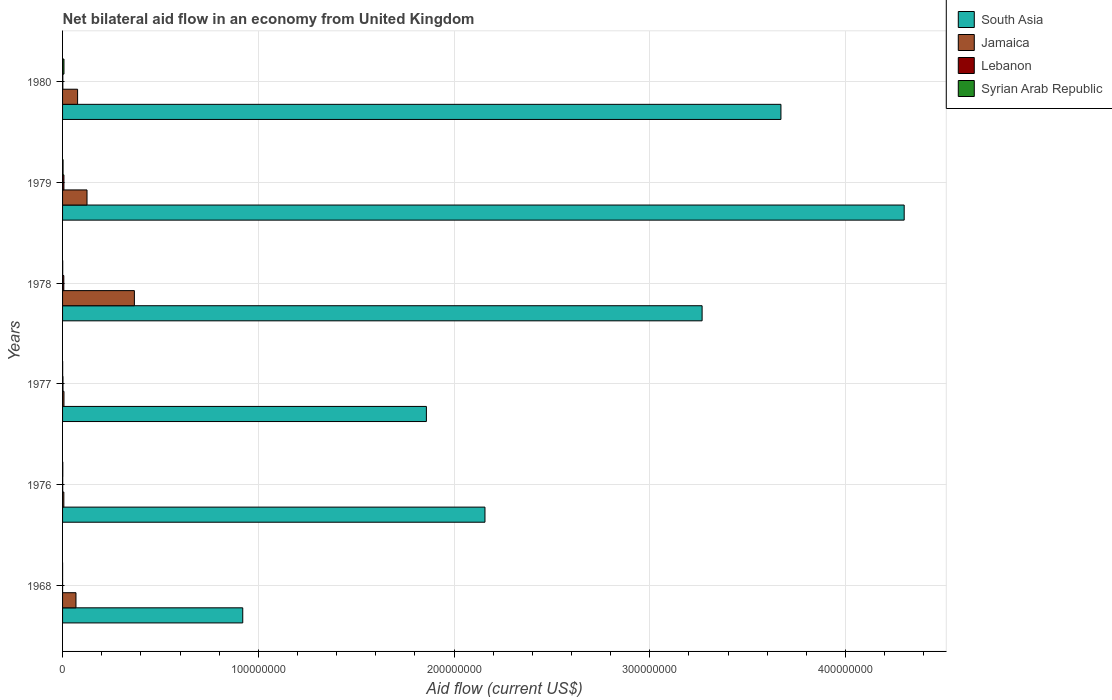What is the label of the 6th group of bars from the top?
Give a very brief answer. 1968. What is the net bilateral aid flow in Lebanon in 1968?
Your answer should be very brief. 10000. Across all years, what is the maximum net bilateral aid flow in Lebanon?
Provide a succinct answer. 6.90e+05. Across all years, what is the minimum net bilateral aid flow in South Asia?
Your response must be concise. 9.20e+07. In which year was the net bilateral aid flow in Syrian Arab Republic maximum?
Offer a very short reply. 1980. In which year was the net bilateral aid flow in Lebanon minimum?
Offer a very short reply. 1968. What is the total net bilateral aid flow in Jamaica in the graph?
Give a very brief answer. 6.51e+07. What is the difference between the net bilateral aid flow in Syrian Arab Republic in 1976 and that in 1978?
Provide a succinct answer. 5.00e+04. What is the difference between the net bilateral aid flow in South Asia in 1968 and the net bilateral aid flow in Lebanon in 1976?
Your answer should be very brief. 9.20e+07. What is the average net bilateral aid flow in Lebanon per year?
Make the answer very short. 2.92e+05. In the year 1978, what is the difference between the net bilateral aid flow in Jamaica and net bilateral aid flow in Syrian Arab Republic?
Keep it short and to the point. 3.66e+07. In how many years, is the net bilateral aid flow in Jamaica greater than 80000000 US$?
Give a very brief answer. 0. What is the difference between the highest and the second highest net bilateral aid flow in South Asia?
Make the answer very short. 6.30e+07. What is the difference between the highest and the lowest net bilateral aid flow in Lebanon?
Your answer should be compact. 6.80e+05. In how many years, is the net bilateral aid flow in Jamaica greater than the average net bilateral aid flow in Jamaica taken over all years?
Your answer should be compact. 2. Is it the case that in every year, the sum of the net bilateral aid flow in Syrian Arab Republic and net bilateral aid flow in Jamaica is greater than the sum of net bilateral aid flow in Lebanon and net bilateral aid flow in South Asia?
Keep it short and to the point. Yes. What does the 4th bar from the top in 1978 represents?
Provide a short and direct response. South Asia. What does the 3rd bar from the bottom in 1980 represents?
Provide a succinct answer. Lebanon. How many bars are there?
Make the answer very short. 24. How many years are there in the graph?
Offer a terse response. 6. What is the difference between two consecutive major ticks on the X-axis?
Make the answer very short. 1.00e+08. Are the values on the major ticks of X-axis written in scientific E-notation?
Provide a succinct answer. No. Does the graph contain grids?
Ensure brevity in your answer.  Yes. Where does the legend appear in the graph?
Provide a short and direct response. Top right. How many legend labels are there?
Your answer should be compact. 4. What is the title of the graph?
Ensure brevity in your answer.  Net bilateral aid flow in an economy from United Kingdom. What is the label or title of the Y-axis?
Your answer should be compact. Years. What is the Aid flow (current US$) in South Asia in 1968?
Your answer should be very brief. 9.20e+07. What is the Aid flow (current US$) in Jamaica in 1968?
Keep it short and to the point. 6.85e+06. What is the Aid flow (current US$) in Lebanon in 1968?
Give a very brief answer. 10000. What is the Aid flow (current US$) of South Asia in 1976?
Offer a very short reply. 2.16e+08. What is the Aid flow (current US$) of Jamaica in 1976?
Give a very brief answer. 6.50e+05. What is the Aid flow (current US$) in Syrian Arab Republic in 1976?
Ensure brevity in your answer.  1.20e+05. What is the Aid flow (current US$) in South Asia in 1977?
Ensure brevity in your answer.  1.86e+08. What is the Aid flow (current US$) in Jamaica in 1977?
Your answer should be compact. 7.20e+05. What is the Aid flow (current US$) in Syrian Arab Republic in 1977?
Offer a very short reply. 5.00e+04. What is the Aid flow (current US$) in South Asia in 1978?
Offer a terse response. 3.27e+08. What is the Aid flow (current US$) of Jamaica in 1978?
Offer a terse response. 3.67e+07. What is the Aid flow (current US$) of Lebanon in 1978?
Your response must be concise. 6.40e+05. What is the Aid flow (current US$) in South Asia in 1979?
Ensure brevity in your answer.  4.30e+08. What is the Aid flow (current US$) of Jamaica in 1979?
Your response must be concise. 1.25e+07. What is the Aid flow (current US$) of Lebanon in 1979?
Offer a terse response. 6.90e+05. What is the Aid flow (current US$) of South Asia in 1980?
Your response must be concise. 3.67e+08. What is the Aid flow (current US$) of Jamaica in 1980?
Keep it short and to the point. 7.68e+06. What is the Aid flow (current US$) in Syrian Arab Republic in 1980?
Your answer should be very brief. 7.20e+05. Across all years, what is the maximum Aid flow (current US$) of South Asia?
Your answer should be compact. 4.30e+08. Across all years, what is the maximum Aid flow (current US$) in Jamaica?
Offer a very short reply. 3.67e+07. Across all years, what is the maximum Aid flow (current US$) of Lebanon?
Offer a very short reply. 6.90e+05. Across all years, what is the maximum Aid flow (current US$) of Syrian Arab Republic?
Offer a terse response. 7.20e+05. Across all years, what is the minimum Aid flow (current US$) in South Asia?
Provide a succinct answer. 9.20e+07. Across all years, what is the minimum Aid flow (current US$) of Jamaica?
Make the answer very short. 6.50e+05. Across all years, what is the minimum Aid flow (current US$) of Lebanon?
Give a very brief answer. 10000. Across all years, what is the minimum Aid flow (current US$) in Syrian Arab Republic?
Give a very brief answer. 10000. What is the total Aid flow (current US$) of South Asia in the graph?
Make the answer very short. 1.62e+09. What is the total Aid flow (current US$) in Jamaica in the graph?
Your answer should be very brief. 6.51e+07. What is the total Aid flow (current US$) in Lebanon in the graph?
Keep it short and to the point. 1.75e+06. What is the total Aid flow (current US$) in Syrian Arab Republic in the graph?
Your response must be concise. 1.22e+06. What is the difference between the Aid flow (current US$) of South Asia in 1968 and that in 1976?
Your response must be concise. -1.24e+08. What is the difference between the Aid flow (current US$) in Jamaica in 1968 and that in 1976?
Provide a short and direct response. 6.20e+06. What is the difference between the Aid flow (current US$) of South Asia in 1968 and that in 1977?
Give a very brief answer. -9.38e+07. What is the difference between the Aid flow (current US$) of Jamaica in 1968 and that in 1977?
Ensure brevity in your answer.  6.13e+06. What is the difference between the Aid flow (current US$) of South Asia in 1968 and that in 1978?
Your answer should be compact. -2.35e+08. What is the difference between the Aid flow (current US$) of Jamaica in 1968 and that in 1978?
Ensure brevity in your answer.  -2.98e+07. What is the difference between the Aid flow (current US$) in Lebanon in 1968 and that in 1978?
Your answer should be very brief. -6.30e+05. What is the difference between the Aid flow (current US$) of Syrian Arab Republic in 1968 and that in 1978?
Ensure brevity in your answer.  -6.00e+04. What is the difference between the Aid flow (current US$) in South Asia in 1968 and that in 1979?
Make the answer very short. -3.38e+08. What is the difference between the Aid flow (current US$) in Jamaica in 1968 and that in 1979?
Your response must be concise. -5.64e+06. What is the difference between the Aid flow (current US$) in Lebanon in 1968 and that in 1979?
Offer a very short reply. -6.80e+05. What is the difference between the Aid flow (current US$) in South Asia in 1968 and that in 1980?
Provide a succinct answer. -2.75e+08. What is the difference between the Aid flow (current US$) of Jamaica in 1968 and that in 1980?
Your answer should be compact. -8.30e+05. What is the difference between the Aid flow (current US$) of Lebanon in 1968 and that in 1980?
Your answer should be compact. -1.20e+05. What is the difference between the Aid flow (current US$) of Syrian Arab Republic in 1968 and that in 1980?
Make the answer very short. -7.10e+05. What is the difference between the Aid flow (current US$) of South Asia in 1976 and that in 1977?
Provide a short and direct response. 2.99e+07. What is the difference between the Aid flow (current US$) of Jamaica in 1976 and that in 1977?
Offer a very short reply. -7.00e+04. What is the difference between the Aid flow (current US$) of Lebanon in 1976 and that in 1977?
Your response must be concise. -1.40e+05. What is the difference between the Aid flow (current US$) in South Asia in 1976 and that in 1978?
Offer a terse response. -1.11e+08. What is the difference between the Aid flow (current US$) of Jamaica in 1976 and that in 1978?
Your answer should be compact. -3.60e+07. What is the difference between the Aid flow (current US$) of Lebanon in 1976 and that in 1978?
Make the answer very short. -5.70e+05. What is the difference between the Aid flow (current US$) in Syrian Arab Republic in 1976 and that in 1978?
Your answer should be very brief. 5.00e+04. What is the difference between the Aid flow (current US$) of South Asia in 1976 and that in 1979?
Provide a short and direct response. -2.14e+08. What is the difference between the Aid flow (current US$) of Jamaica in 1976 and that in 1979?
Provide a succinct answer. -1.18e+07. What is the difference between the Aid flow (current US$) of Lebanon in 1976 and that in 1979?
Your response must be concise. -6.20e+05. What is the difference between the Aid flow (current US$) in Syrian Arab Republic in 1976 and that in 1979?
Give a very brief answer. -1.30e+05. What is the difference between the Aid flow (current US$) of South Asia in 1976 and that in 1980?
Provide a succinct answer. -1.51e+08. What is the difference between the Aid flow (current US$) of Jamaica in 1976 and that in 1980?
Your response must be concise. -7.03e+06. What is the difference between the Aid flow (current US$) of Lebanon in 1976 and that in 1980?
Keep it short and to the point. -6.00e+04. What is the difference between the Aid flow (current US$) in Syrian Arab Republic in 1976 and that in 1980?
Ensure brevity in your answer.  -6.00e+05. What is the difference between the Aid flow (current US$) of South Asia in 1977 and that in 1978?
Make the answer very short. -1.41e+08. What is the difference between the Aid flow (current US$) in Jamaica in 1977 and that in 1978?
Provide a short and direct response. -3.60e+07. What is the difference between the Aid flow (current US$) in Lebanon in 1977 and that in 1978?
Give a very brief answer. -4.30e+05. What is the difference between the Aid flow (current US$) in South Asia in 1977 and that in 1979?
Provide a succinct answer. -2.44e+08. What is the difference between the Aid flow (current US$) in Jamaica in 1977 and that in 1979?
Provide a short and direct response. -1.18e+07. What is the difference between the Aid flow (current US$) in Lebanon in 1977 and that in 1979?
Provide a short and direct response. -4.80e+05. What is the difference between the Aid flow (current US$) of Syrian Arab Republic in 1977 and that in 1979?
Provide a short and direct response. -2.00e+05. What is the difference between the Aid flow (current US$) of South Asia in 1977 and that in 1980?
Ensure brevity in your answer.  -1.81e+08. What is the difference between the Aid flow (current US$) of Jamaica in 1977 and that in 1980?
Make the answer very short. -6.96e+06. What is the difference between the Aid flow (current US$) of Lebanon in 1977 and that in 1980?
Your answer should be compact. 8.00e+04. What is the difference between the Aid flow (current US$) in Syrian Arab Republic in 1977 and that in 1980?
Your answer should be compact. -6.70e+05. What is the difference between the Aid flow (current US$) in South Asia in 1978 and that in 1979?
Offer a terse response. -1.03e+08. What is the difference between the Aid flow (current US$) in Jamaica in 1978 and that in 1979?
Your response must be concise. 2.42e+07. What is the difference between the Aid flow (current US$) in Syrian Arab Republic in 1978 and that in 1979?
Your response must be concise. -1.80e+05. What is the difference between the Aid flow (current US$) of South Asia in 1978 and that in 1980?
Make the answer very short. -4.03e+07. What is the difference between the Aid flow (current US$) of Jamaica in 1978 and that in 1980?
Provide a succinct answer. 2.90e+07. What is the difference between the Aid flow (current US$) of Lebanon in 1978 and that in 1980?
Keep it short and to the point. 5.10e+05. What is the difference between the Aid flow (current US$) in Syrian Arab Republic in 1978 and that in 1980?
Your answer should be compact. -6.50e+05. What is the difference between the Aid flow (current US$) in South Asia in 1979 and that in 1980?
Offer a terse response. 6.30e+07. What is the difference between the Aid flow (current US$) in Jamaica in 1979 and that in 1980?
Offer a very short reply. 4.81e+06. What is the difference between the Aid flow (current US$) in Lebanon in 1979 and that in 1980?
Provide a short and direct response. 5.60e+05. What is the difference between the Aid flow (current US$) in Syrian Arab Republic in 1979 and that in 1980?
Your answer should be very brief. -4.70e+05. What is the difference between the Aid flow (current US$) of South Asia in 1968 and the Aid flow (current US$) of Jamaica in 1976?
Your answer should be compact. 9.14e+07. What is the difference between the Aid flow (current US$) in South Asia in 1968 and the Aid flow (current US$) in Lebanon in 1976?
Make the answer very short. 9.20e+07. What is the difference between the Aid flow (current US$) in South Asia in 1968 and the Aid flow (current US$) in Syrian Arab Republic in 1976?
Your response must be concise. 9.19e+07. What is the difference between the Aid flow (current US$) of Jamaica in 1968 and the Aid flow (current US$) of Lebanon in 1976?
Provide a succinct answer. 6.78e+06. What is the difference between the Aid flow (current US$) in Jamaica in 1968 and the Aid flow (current US$) in Syrian Arab Republic in 1976?
Provide a short and direct response. 6.73e+06. What is the difference between the Aid flow (current US$) in Lebanon in 1968 and the Aid flow (current US$) in Syrian Arab Republic in 1976?
Provide a short and direct response. -1.10e+05. What is the difference between the Aid flow (current US$) of South Asia in 1968 and the Aid flow (current US$) of Jamaica in 1977?
Keep it short and to the point. 9.13e+07. What is the difference between the Aid flow (current US$) in South Asia in 1968 and the Aid flow (current US$) in Lebanon in 1977?
Provide a succinct answer. 9.18e+07. What is the difference between the Aid flow (current US$) of South Asia in 1968 and the Aid flow (current US$) of Syrian Arab Republic in 1977?
Your response must be concise. 9.20e+07. What is the difference between the Aid flow (current US$) in Jamaica in 1968 and the Aid flow (current US$) in Lebanon in 1977?
Offer a terse response. 6.64e+06. What is the difference between the Aid flow (current US$) of Jamaica in 1968 and the Aid flow (current US$) of Syrian Arab Republic in 1977?
Offer a very short reply. 6.80e+06. What is the difference between the Aid flow (current US$) of Lebanon in 1968 and the Aid flow (current US$) of Syrian Arab Republic in 1977?
Offer a terse response. -4.00e+04. What is the difference between the Aid flow (current US$) of South Asia in 1968 and the Aid flow (current US$) of Jamaica in 1978?
Offer a terse response. 5.54e+07. What is the difference between the Aid flow (current US$) in South Asia in 1968 and the Aid flow (current US$) in Lebanon in 1978?
Make the answer very short. 9.14e+07. What is the difference between the Aid flow (current US$) in South Asia in 1968 and the Aid flow (current US$) in Syrian Arab Republic in 1978?
Provide a succinct answer. 9.20e+07. What is the difference between the Aid flow (current US$) in Jamaica in 1968 and the Aid flow (current US$) in Lebanon in 1978?
Ensure brevity in your answer.  6.21e+06. What is the difference between the Aid flow (current US$) in Jamaica in 1968 and the Aid flow (current US$) in Syrian Arab Republic in 1978?
Make the answer very short. 6.78e+06. What is the difference between the Aid flow (current US$) of South Asia in 1968 and the Aid flow (current US$) of Jamaica in 1979?
Provide a short and direct response. 7.96e+07. What is the difference between the Aid flow (current US$) of South Asia in 1968 and the Aid flow (current US$) of Lebanon in 1979?
Keep it short and to the point. 9.14e+07. What is the difference between the Aid flow (current US$) of South Asia in 1968 and the Aid flow (current US$) of Syrian Arab Republic in 1979?
Offer a terse response. 9.18e+07. What is the difference between the Aid flow (current US$) of Jamaica in 1968 and the Aid flow (current US$) of Lebanon in 1979?
Give a very brief answer. 6.16e+06. What is the difference between the Aid flow (current US$) of Jamaica in 1968 and the Aid flow (current US$) of Syrian Arab Republic in 1979?
Your answer should be compact. 6.60e+06. What is the difference between the Aid flow (current US$) of Lebanon in 1968 and the Aid flow (current US$) of Syrian Arab Republic in 1979?
Provide a succinct answer. -2.40e+05. What is the difference between the Aid flow (current US$) in South Asia in 1968 and the Aid flow (current US$) in Jamaica in 1980?
Ensure brevity in your answer.  8.44e+07. What is the difference between the Aid flow (current US$) in South Asia in 1968 and the Aid flow (current US$) in Lebanon in 1980?
Your answer should be compact. 9.19e+07. What is the difference between the Aid flow (current US$) of South Asia in 1968 and the Aid flow (current US$) of Syrian Arab Republic in 1980?
Give a very brief answer. 9.13e+07. What is the difference between the Aid flow (current US$) of Jamaica in 1968 and the Aid flow (current US$) of Lebanon in 1980?
Give a very brief answer. 6.72e+06. What is the difference between the Aid flow (current US$) in Jamaica in 1968 and the Aid flow (current US$) in Syrian Arab Republic in 1980?
Your answer should be compact. 6.13e+06. What is the difference between the Aid flow (current US$) in Lebanon in 1968 and the Aid flow (current US$) in Syrian Arab Republic in 1980?
Your answer should be very brief. -7.10e+05. What is the difference between the Aid flow (current US$) of South Asia in 1976 and the Aid flow (current US$) of Jamaica in 1977?
Your answer should be compact. 2.15e+08. What is the difference between the Aid flow (current US$) of South Asia in 1976 and the Aid flow (current US$) of Lebanon in 1977?
Keep it short and to the point. 2.16e+08. What is the difference between the Aid flow (current US$) of South Asia in 1976 and the Aid flow (current US$) of Syrian Arab Republic in 1977?
Your answer should be compact. 2.16e+08. What is the difference between the Aid flow (current US$) of Lebanon in 1976 and the Aid flow (current US$) of Syrian Arab Republic in 1977?
Provide a succinct answer. 2.00e+04. What is the difference between the Aid flow (current US$) in South Asia in 1976 and the Aid flow (current US$) in Jamaica in 1978?
Your answer should be compact. 1.79e+08. What is the difference between the Aid flow (current US$) in South Asia in 1976 and the Aid flow (current US$) in Lebanon in 1978?
Provide a succinct answer. 2.15e+08. What is the difference between the Aid flow (current US$) of South Asia in 1976 and the Aid flow (current US$) of Syrian Arab Republic in 1978?
Make the answer very short. 2.16e+08. What is the difference between the Aid flow (current US$) of Jamaica in 1976 and the Aid flow (current US$) of Lebanon in 1978?
Your answer should be very brief. 10000. What is the difference between the Aid flow (current US$) of Jamaica in 1976 and the Aid flow (current US$) of Syrian Arab Republic in 1978?
Your response must be concise. 5.80e+05. What is the difference between the Aid flow (current US$) in South Asia in 1976 and the Aid flow (current US$) in Jamaica in 1979?
Provide a short and direct response. 2.03e+08. What is the difference between the Aid flow (current US$) of South Asia in 1976 and the Aid flow (current US$) of Lebanon in 1979?
Ensure brevity in your answer.  2.15e+08. What is the difference between the Aid flow (current US$) of South Asia in 1976 and the Aid flow (current US$) of Syrian Arab Republic in 1979?
Make the answer very short. 2.16e+08. What is the difference between the Aid flow (current US$) of Jamaica in 1976 and the Aid flow (current US$) of Syrian Arab Republic in 1979?
Provide a short and direct response. 4.00e+05. What is the difference between the Aid flow (current US$) of South Asia in 1976 and the Aid flow (current US$) of Jamaica in 1980?
Your answer should be very brief. 2.08e+08. What is the difference between the Aid flow (current US$) in South Asia in 1976 and the Aid flow (current US$) in Lebanon in 1980?
Your answer should be compact. 2.16e+08. What is the difference between the Aid flow (current US$) in South Asia in 1976 and the Aid flow (current US$) in Syrian Arab Republic in 1980?
Your response must be concise. 2.15e+08. What is the difference between the Aid flow (current US$) in Jamaica in 1976 and the Aid flow (current US$) in Lebanon in 1980?
Your response must be concise. 5.20e+05. What is the difference between the Aid flow (current US$) of Lebanon in 1976 and the Aid flow (current US$) of Syrian Arab Republic in 1980?
Keep it short and to the point. -6.50e+05. What is the difference between the Aid flow (current US$) of South Asia in 1977 and the Aid flow (current US$) of Jamaica in 1978?
Offer a very short reply. 1.49e+08. What is the difference between the Aid flow (current US$) in South Asia in 1977 and the Aid flow (current US$) in Lebanon in 1978?
Keep it short and to the point. 1.85e+08. What is the difference between the Aid flow (current US$) in South Asia in 1977 and the Aid flow (current US$) in Syrian Arab Republic in 1978?
Your answer should be compact. 1.86e+08. What is the difference between the Aid flow (current US$) of Jamaica in 1977 and the Aid flow (current US$) of Lebanon in 1978?
Your response must be concise. 8.00e+04. What is the difference between the Aid flow (current US$) in Jamaica in 1977 and the Aid flow (current US$) in Syrian Arab Republic in 1978?
Offer a terse response. 6.50e+05. What is the difference between the Aid flow (current US$) of Lebanon in 1977 and the Aid flow (current US$) of Syrian Arab Republic in 1978?
Make the answer very short. 1.40e+05. What is the difference between the Aid flow (current US$) of South Asia in 1977 and the Aid flow (current US$) of Jamaica in 1979?
Provide a succinct answer. 1.73e+08. What is the difference between the Aid flow (current US$) of South Asia in 1977 and the Aid flow (current US$) of Lebanon in 1979?
Ensure brevity in your answer.  1.85e+08. What is the difference between the Aid flow (current US$) in South Asia in 1977 and the Aid flow (current US$) in Syrian Arab Republic in 1979?
Provide a short and direct response. 1.86e+08. What is the difference between the Aid flow (current US$) of Jamaica in 1977 and the Aid flow (current US$) of Syrian Arab Republic in 1979?
Your answer should be very brief. 4.70e+05. What is the difference between the Aid flow (current US$) of South Asia in 1977 and the Aid flow (current US$) of Jamaica in 1980?
Provide a succinct answer. 1.78e+08. What is the difference between the Aid flow (current US$) in South Asia in 1977 and the Aid flow (current US$) in Lebanon in 1980?
Your response must be concise. 1.86e+08. What is the difference between the Aid flow (current US$) in South Asia in 1977 and the Aid flow (current US$) in Syrian Arab Republic in 1980?
Offer a very short reply. 1.85e+08. What is the difference between the Aid flow (current US$) in Jamaica in 1977 and the Aid flow (current US$) in Lebanon in 1980?
Ensure brevity in your answer.  5.90e+05. What is the difference between the Aid flow (current US$) of Jamaica in 1977 and the Aid flow (current US$) of Syrian Arab Republic in 1980?
Ensure brevity in your answer.  0. What is the difference between the Aid flow (current US$) in Lebanon in 1977 and the Aid flow (current US$) in Syrian Arab Republic in 1980?
Provide a succinct answer. -5.10e+05. What is the difference between the Aid flow (current US$) in South Asia in 1978 and the Aid flow (current US$) in Jamaica in 1979?
Provide a short and direct response. 3.14e+08. What is the difference between the Aid flow (current US$) in South Asia in 1978 and the Aid flow (current US$) in Lebanon in 1979?
Provide a succinct answer. 3.26e+08. What is the difference between the Aid flow (current US$) of South Asia in 1978 and the Aid flow (current US$) of Syrian Arab Republic in 1979?
Provide a succinct answer. 3.26e+08. What is the difference between the Aid flow (current US$) in Jamaica in 1978 and the Aid flow (current US$) in Lebanon in 1979?
Offer a terse response. 3.60e+07. What is the difference between the Aid flow (current US$) in Jamaica in 1978 and the Aid flow (current US$) in Syrian Arab Republic in 1979?
Your response must be concise. 3.64e+07. What is the difference between the Aid flow (current US$) of Lebanon in 1978 and the Aid flow (current US$) of Syrian Arab Republic in 1979?
Your response must be concise. 3.90e+05. What is the difference between the Aid flow (current US$) of South Asia in 1978 and the Aid flow (current US$) of Jamaica in 1980?
Ensure brevity in your answer.  3.19e+08. What is the difference between the Aid flow (current US$) in South Asia in 1978 and the Aid flow (current US$) in Lebanon in 1980?
Provide a succinct answer. 3.27e+08. What is the difference between the Aid flow (current US$) in South Asia in 1978 and the Aid flow (current US$) in Syrian Arab Republic in 1980?
Give a very brief answer. 3.26e+08. What is the difference between the Aid flow (current US$) in Jamaica in 1978 and the Aid flow (current US$) in Lebanon in 1980?
Provide a short and direct response. 3.66e+07. What is the difference between the Aid flow (current US$) of Jamaica in 1978 and the Aid flow (current US$) of Syrian Arab Republic in 1980?
Keep it short and to the point. 3.60e+07. What is the difference between the Aid flow (current US$) of South Asia in 1979 and the Aid flow (current US$) of Jamaica in 1980?
Keep it short and to the point. 4.22e+08. What is the difference between the Aid flow (current US$) of South Asia in 1979 and the Aid flow (current US$) of Lebanon in 1980?
Your answer should be very brief. 4.30e+08. What is the difference between the Aid flow (current US$) in South Asia in 1979 and the Aid flow (current US$) in Syrian Arab Republic in 1980?
Offer a very short reply. 4.29e+08. What is the difference between the Aid flow (current US$) in Jamaica in 1979 and the Aid flow (current US$) in Lebanon in 1980?
Offer a very short reply. 1.24e+07. What is the difference between the Aid flow (current US$) in Jamaica in 1979 and the Aid flow (current US$) in Syrian Arab Republic in 1980?
Provide a short and direct response. 1.18e+07. What is the average Aid flow (current US$) of South Asia per year?
Give a very brief answer. 2.70e+08. What is the average Aid flow (current US$) of Jamaica per year?
Keep it short and to the point. 1.08e+07. What is the average Aid flow (current US$) in Lebanon per year?
Give a very brief answer. 2.92e+05. What is the average Aid flow (current US$) in Syrian Arab Republic per year?
Provide a succinct answer. 2.03e+05. In the year 1968, what is the difference between the Aid flow (current US$) in South Asia and Aid flow (current US$) in Jamaica?
Your answer should be compact. 8.52e+07. In the year 1968, what is the difference between the Aid flow (current US$) in South Asia and Aid flow (current US$) in Lebanon?
Offer a terse response. 9.20e+07. In the year 1968, what is the difference between the Aid flow (current US$) in South Asia and Aid flow (current US$) in Syrian Arab Republic?
Your answer should be very brief. 9.20e+07. In the year 1968, what is the difference between the Aid flow (current US$) of Jamaica and Aid flow (current US$) of Lebanon?
Keep it short and to the point. 6.84e+06. In the year 1968, what is the difference between the Aid flow (current US$) in Jamaica and Aid flow (current US$) in Syrian Arab Republic?
Ensure brevity in your answer.  6.84e+06. In the year 1976, what is the difference between the Aid flow (current US$) in South Asia and Aid flow (current US$) in Jamaica?
Offer a very short reply. 2.15e+08. In the year 1976, what is the difference between the Aid flow (current US$) of South Asia and Aid flow (current US$) of Lebanon?
Provide a succinct answer. 2.16e+08. In the year 1976, what is the difference between the Aid flow (current US$) in South Asia and Aid flow (current US$) in Syrian Arab Republic?
Keep it short and to the point. 2.16e+08. In the year 1976, what is the difference between the Aid flow (current US$) in Jamaica and Aid flow (current US$) in Lebanon?
Give a very brief answer. 5.80e+05. In the year 1976, what is the difference between the Aid flow (current US$) in Jamaica and Aid flow (current US$) in Syrian Arab Republic?
Offer a terse response. 5.30e+05. In the year 1977, what is the difference between the Aid flow (current US$) in South Asia and Aid flow (current US$) in Jamaica?
Your response must be concise. 1.85e+08. In the year 1977, what is the difference between the Aid flow (current US$) in South Asia and Aid flow (current US$) in Lebanon?
Your answer should be compact. 1.86e+08. In the year 1977, what is the difference between the Aid flow (current US$) of South Asia and Aid flow (current US$) of Syrian Arab Republic?
Your answer should be very brief. 1.86e+08. In the year 1977, what is the difference between the Aid flow (current US$) of Jamaica and Aid flow (current US$) of Lebanon?
Your answer should be compact. 5.10e+05. In the year 1977, what is the difference between the Aid flow (current US$) in Jamaica and Aid flow (current US$) in Syrian Arab Republic?
Make the answer very short. 6.70e+05. In the year 1978, what is the difference between the Aid flow (current US$) of South Asia and Aid flow (current US$) of Jamaica?
Make the answer very short. 2.90e+08. In the year 1978, what is the difference between the Aid flow (current US$) in South Asia and Aid flow (current US$) in Lebanon?
Offer a terse response. 3.26e+08. In the year 1978, what is the difference between the Aid flow (current US$) of South Asia and Aid flow (current US$) of Syrian Arab Republic?
Your answer should be very brief. 3.27e+08. In the year 1978, what is the difference between the Aid flow (current US$) in Jamaica and Aid flow (current US$) in Lebanon?
Provide a succinct answer. 3.60e+07. In the year 1978, what is the difference between the Aid flow (current US$) of Jamaica and Aid flow (current US$) of Syrian Arab Republic?
Keep it short and to the point. 3.66e+07. In the year 1978, what is the difference between the Aid flow (current US$) of Lebanon and Aid flow (current US$) of Syrian Arab Republic?
Provide a succinct answer. 5.70e+05. In the year 1979, what is the difference between the Aid flow (current US$) in South Asia and Aid flow (current US$) in Jamaica?
Make the answer very short. 4.17e+08. In the year 1979, what is the difference between the Aid flow (current US$) in South Asia and Aid flow (current US$) in Lebanon?
Provide a short and direct response. 4.29e+08. In the year 1979, what is the difference between the Aid flow (current US$) in South Asia and Aid flow (current US$) in Syrian Arab Republic?
Offer a terse response. 4.30e+08. In the year 1979, what is the difference between the Aid flow (current US$) of Jamaica and Aid flow (current US$) of Lebanon?
Offer a very short reply. 1.18e+07. In the year 1979, what is the difference between the Aid flow (current US$) in Jamaica and Aid flow (current US$) in Syrian Arab Republic?
Your response must be concise. 1.22e+07. In the year 1980, what is the difference between the Aid flow (current US$) in South Asia and Aid flow (current US$) in Jamaica?
Give a very brief answer. 3.59e+08. In the year 1980, what is the difference between the Aid flow (current US$) of South Asia and Aid flow (current US$) of Lebanon?
Your response must be concise. 3.67e+08. In the year 1980, what is the difference between the Aid flow (current US$) of South Asia and Aid flow (current US$) of Syrian Arab Republic?
Provide a succinct answer. 3.66e+08. In the year 1980, what is the difference between the Aid flow (current US$) of Jamaica and Aid flow (current US$) of Lebanon?
Ensure brevity in your answer.  7.55e+06. In the year 1980, what is the difference between the Aid flow (current US$) in Jamaica and Aid flow (current US$) in Syrian Arab Republic?
Provide a short and direct response. 6.96e+06. In the year 1980, what is the difference between the Aid flow (current US$) in Lebanon and Aid flow (current US$) in Syrian Arab Republic?
Your answer should be compact. -5.90e+05. What is the ratio of the Aid flow (current US$) in South Asia in 1968 to that in 1976?
Offer a terse response. 0.43. What is the ratio of the Aid flow (current US$) of Jamaica in 1968 to that in 1976?
Give a very brief answer. 10.54. What is the ratio of the Aid flow (current US$) in Lebanon in 1968 to that in 1976?
Make the answer very short. 0.14. What is the ratio of the Aid flow (current US$) in Syrian Arab Republic in 1968 to that in 1976?
Your response must be concise. 0.08. What is the ratio of the Aid flow (current US$) in South Asia in 1968 to that in 1977?
Give a very brief answer. 0.5. What is the ratio of the Aid flow (current US$) of Jamaica in 1968 to that in 1977?
Offer a terse response. 9.51. What is the ratio of the Aid flow (current US$) of Lebanon in 1968 to that in 1977?
Your answer should be compact. 0.05. What is the ratio of the Aid flow (current US$) in Syrian Arab Republic in 1968 to that in 1977?
Provide a short and direct response. 0.2. What is the ratio of the Aid flow (current US$) of South Asia in 1968 to that in 1978?
Offer a very short reply. 0.28. What is the ratio of the Aid flow (current US$) of Jamaica in 1968 to that in 1978?
Your answer should be very brief. 0.19. What is the ratio of the Aid flow (current US$) in Lebanon in 1968 to that in 1978?
Give a very brief answer. 0.02. What is the ratio of the Aid flow (current US$) of Syrian Arab Republic in 1968 to that in 1978?
Your answer should be compact. 0.14. What is the ratio of the Aid flow (current US$) in South Asia in 1968 to that in 1979?
Your answer should be very brief. 0.21. What is the ratio of the Aid flow (current US$) in Jamaica in 1968 to that in 1979?
Your response must be concise. 0.55. What is the ratio of the Aid flow (current US$) in Lebanon in 1968 to that in 1979?
Provide a short and direct response. 0.01. What is the ratio of the Aid flow (current US$) in Syrian Arab Republic in 1968 to that in 1979?
Give a very brief answer. 0.04. What is the ratio of the Aid flow (current US$) in South Asia in 1968 to that in 1980?
Ensure brevity in your answer.  0.25. What is the ratio of the Aid flow (current US$) of Jamaica in 1968 to that in 1980?
Make the answer very short. 0.89. What is the ratio of the Aid flow (current US$) in Lebanon in 1968 to that in 1980?
Offer a very short reply. 0.08. What is the ratio of the Aid flow (current US$) of Syrian Arab Republic in 1968 to that in 1980?
Make the answer very short. 0.01. What is the ratio of the Aid flow (current US$) in South Asia in 1976 to that in 1977?
Give a very brief answer. 1.16. What is the ratio of the Aid flow (current US$) in Jamaica in 1976 to that in 1977?
Make the answer very short. 0.9. What is the ratio of the Aid flow (current US$) of Lebanon in 1976 to that in 1977?
Provide a short and direct response. 0.33. What is the ratio of the Aid flow (current US$) in South Asia in 1976 to that in 1978?
Offer a terse response. 0.66. What is the ratio of the Aid flow (current US$) in Jamaica in 1976 to that in 1978?
Make the answer very short. 0.02. What is the ratio of the Aid flow (current US$) in Lebanon in 1976 to that in 1978?
Offer a terse response. 0.11. What is the ratio of the Aid flow (current US$) of Syrian Arab Republic in 1976 to that in 1978?
Make the answer very short. 1.71. What is the ratio of the Aid flow (current US$) in South Asia in 1976 to that in 1979?
Offer a terse response. 0.5. What is the ratio of the Aid flow (current US$) in Jamaica in 1976 to that in 1979?
Provide a succinct answer. 0.05. What is the ratio of the Aid flow (current US$) of Lebanon in 1976 to that in 1979?
Your answer should be compact. 0.1. What is the ratio of the Aid flow (current US$) in Syrian Arab Republic in 1976 to that in 1979?
Keep it short and to the point. 0.48. What is the ratio of the Aid flow (current US$) in South Asia in 1976 to that in 1980?
Your answer should be very brief. 0.59. What is the ratio of the Aid flow (current US$) of Jamaica in 1976 to that in 1980?
Provide a succinct answer. 0.08. What is the ratio of the Aid flow (current US$) of Lebanon in 1976 to that in 1980?
Make the answer very short. 0.54. What is the ratio of the Aid flow (current US$) in South Asia in 1977 to that in 1978?
Keep it short and to the point. 0.57. What is the ratio of the Aid flow (current US$) of Jamaica in 1977 to that in 1978?
Provide a short and direct response. 0.02. What is the ratio of the Aid flow (current US$) in Lebanon in 1977 to that in 1978?
Offer a terse response. 0.33. What is the ratio of the Aid flow (current US$) of Syrian Arab Republic in 1977 to that in 1978?
Keep it short and to the point. 0.71. What is the ratio of the Aid flow (current US$) in South Asia in 1977 to that in 1979?
Keep it short and to the point. 0.43. What is the ratio of the Aid flow (current US$) of Jamaica in 1977 to that in 1979?
Give a very brief answer. 0.06. What is the ratio of the Aid flow (current US$) of Lebanon in 1977 to that in 1979?
Offer a very short reply. 0.3. What is the ratio of the Aid flow (current US$) in South Asia in 1977 to that in 1980?
Provide a succinct answer. 0.51. What is the ratio of the Aid flow (current US$) of Jamaica in 1977 to that in 1980?
Offer a very short reply. 0.09. What is the ratio of the Aid flow (current US$) of Lebanon in 1977 to that in 1980?
Provide a succinct answer. 1.62. What is the ratio of the Aid flow (current US$) in Syrian Arab Republic in 1977 to that in 1980?
Give a very brief answer. 0.07. What is the ratio of the Aid flow (current US$) in South Asia in 1978 to that in 1979?
Ensure brevity in your answer.  0.76. What is the ratio of the Aid flow (current US$) of Jamaica in 1978 to that in 1979?
Provide a succinct answer. 2.94. What is the ratio of the Aid flow (current US$) of Lebanon in 1978 to that in 1979?
Provide a short and direct response. 0.93. What is the ratio of the Aid flow (current US$) in Syrian Arab Republic in 1978 to that in 1979?
Your answer should be compact. 0.28. What is the ratio of the Aid flow (current US$) in South Asia in 1978 to that in 1980?
Offer a terse response. 0.89. What is the ratio of the Aid flow (current US$) in Jamaica in 1978 to that in 1980?
Make the answer very short. 4.78. What is the ratio of the Aid flow (current US$) of Lebanon in 1978 to that in 1980?
Provide a succinct answer. 4.92. What is the ratio of the Aid flow (current US$) of Syrian Arab Republic in 1978 to that in 1980?
Offer a very short reply. 0.1. What is the ratio of the Aid flow (current US$) of South Asia in 1979 to that in 1980?
Ensure brevity in your answer.  1.17. What is the ratio of the Aid flow (current US$) in Jamaica in 1979 to that in 1980?
Your answer should be very brief. 1.63. What is the ratio of the Aid flow (current US$) of Lebanon in 1979 to that in 1980?
Keep it short and to the point. 5.31. What is the ratio of the Aid flow (current US$) in Syrian Arab Republic in 1979 to that in 1980?
Give a very brief answer. 0.35. What is the difference between the highest and the second highest Aid flow (current US$) in South Asia?
Offer a terse response. 6.30e+07. What is the difference between the highest and the second highest Aid flow (current US$) of Jamaica?
Your answer should be compact. 2.42e+07. What is the difference between the highest and the second highest Aid flow (current US$) of Syrian Arab Republic?
Provide a succinct answer. 4.70e+05. What is the difference between the highest and the lowest Aid flow (current US$) of South Asia?
Provide a short and direct response. 3.38e+08. What is the difference between the highest and the lowest Aid flow (current US$) of Jamaica?
Provide a succinct answer. 3.60e+07. What is the difference between the highest and the lowest Aid flow (current US$) of Lebanon?
Your answer should be very brief. 6.80e+05. What is the difference between the highest and the lowest Aid flow (current US$) in Syrian Arab Republic?
Offer a very short reply. 7.10e+05. 